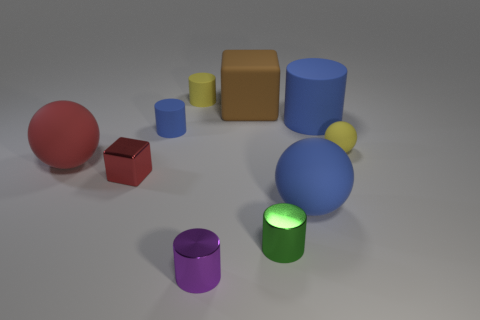Subtract all blue matte balls. How many balls are left? 2 Subtract all red balls. How many blue cylinders are left? 2 Subtract all purple cylinders. How many cylinders are left? 4 Add 7 red spheres. How many red spheres are left? 8 Add 4 blue cylinders. How many blue cylinders exist? 6 Subtract 1 yellow balls. How many objects are left? 9 Subtract all spheres. How many objects are left? 7 Subtract all blue cylinders. Subtract all gray blocks. How many cylinders are left? 3 Subtract all blocks. Subtract all shiny things. How many objects are left? 5 